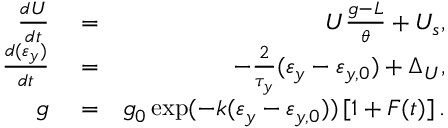<formula> <loc_0><loc_0><loc_500><loc_500>\begin{array} { r l r } { \frac { d U } { d t } } & = } & { U \frac { g - L } { \theta } + U _ { s } , } \\ { \frac { d ( \varepsilon _ { y } ) } { d t } } & = } & { - \frac { 2 } { \tau _ { y } } ( \varepsilon _ { y } - \varepsilon _ { y , 0 } ) + \Delta _ { U } , } \\ { g } & = } & { g _ { 0 } \exp ( - k ( \varepsilon _ { y } - \varepsilon _ { y , 0 } ) ) \left [ 1 + F ( t ) \right ] . } \end{array}</formula> 